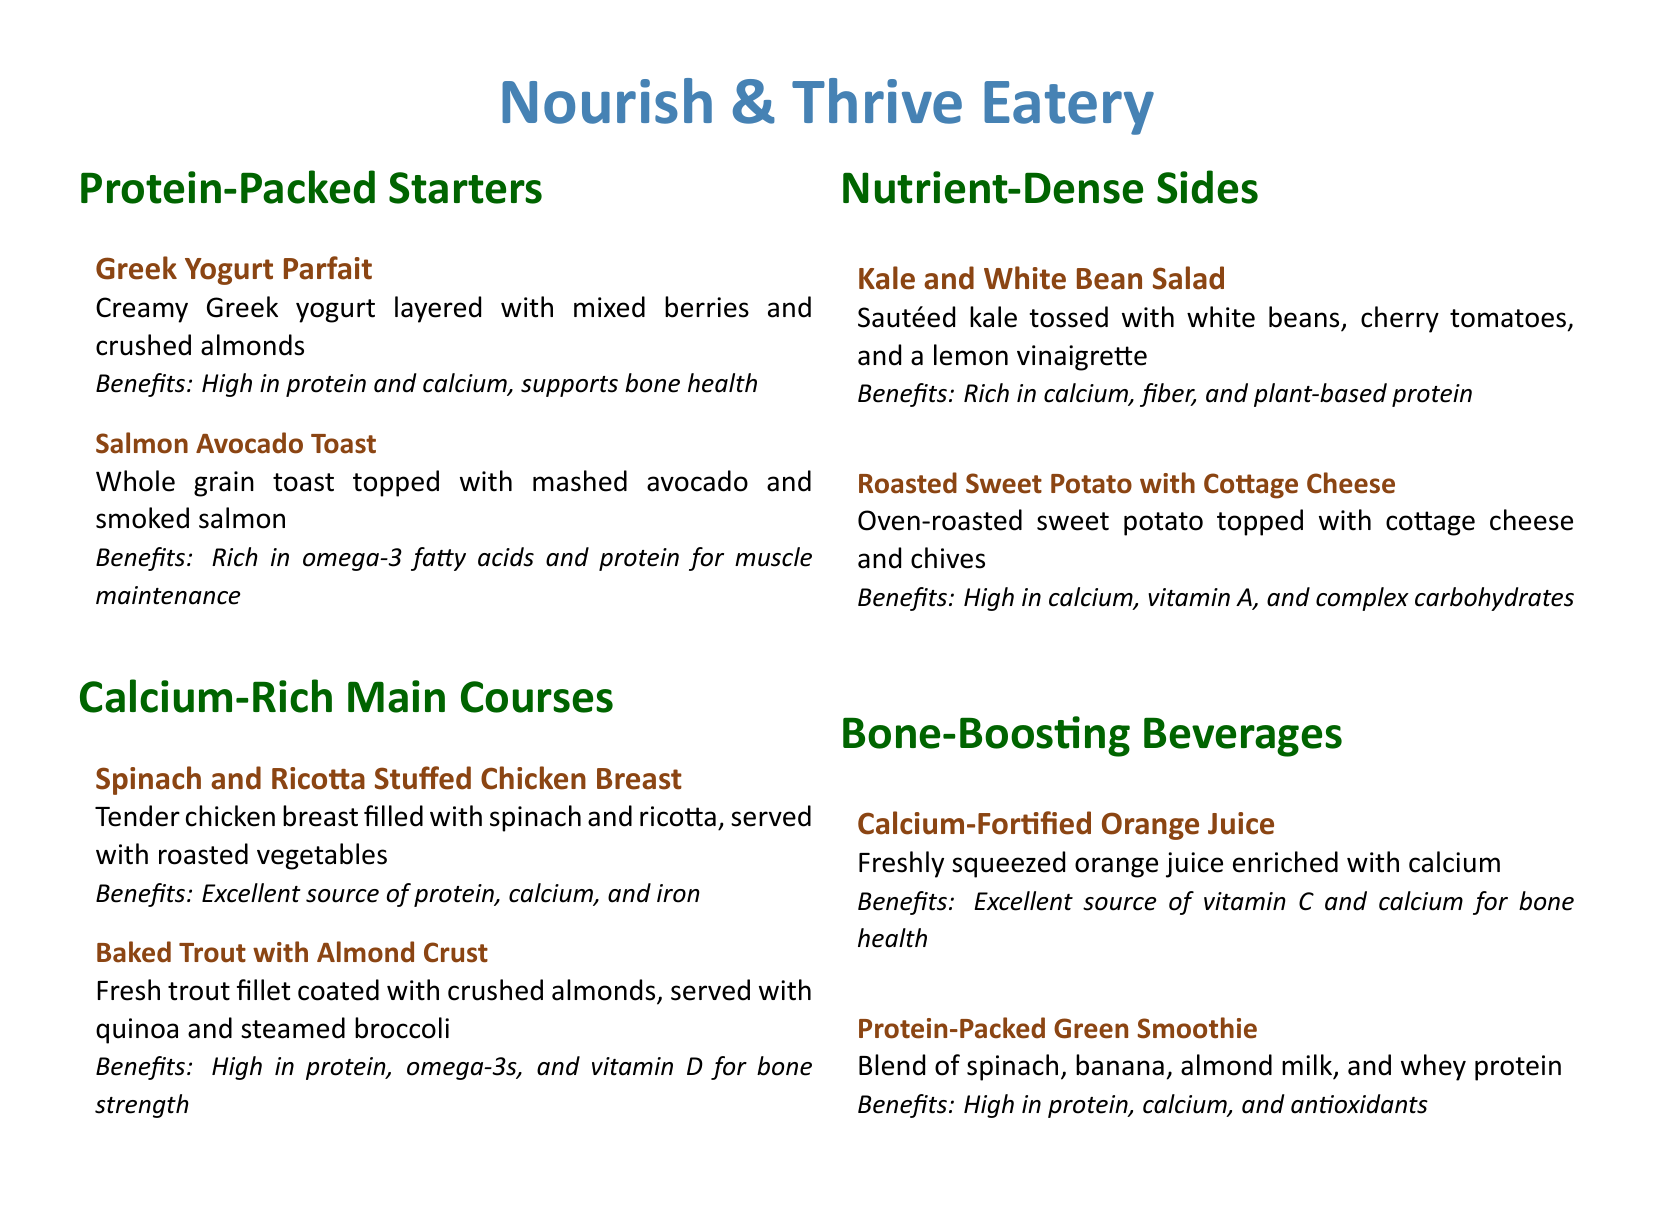What is the first item listed under Protein-Packed Starters? The first item listed is specifically mentioned as Greek Yogurt Parfait.
Answer: Greek Yogurt Parfait What two main ingredients are in the Salmon Avocado Toast? The main ingredients are outlined in the description of the item.
Answer: Avocado and smoked salmon How many main courses are described in the menu? The total number of main courses is stated under their respective section.
Answer: Two What is the benefit of the Spinach and Ricotta Stuffed Chicken Breast? The benefits are summarized in the description associated with the dish.
Answer: Excellent source of protein, calcium, and iron What is the primary source of calcium in the Roasted Sweet Potato with Cottage Cheese? The dish's description highlights the main ingredient providing calcium.
Answer: Cottage cheese Which beverage is enriched with calcium? This question is asking about the beverages available in the menu and their benefits.
Answer: Calcium-Fortified Orange Juice What type of protein is included in the Protein-Packed Green Smoothie? The description specifies the type of protein included in the smoothie.
Answer: Whey protein Which side dish is rich in fiber? The nutrient content of each side dish is provided, allowing for this determination.
Answer: Kale and White Bean Salad What cooking method is used for the Baked Trout with Almond Crust? The cooking technique for preparing the trout is mentioned in the item description.
Answer: Baked 